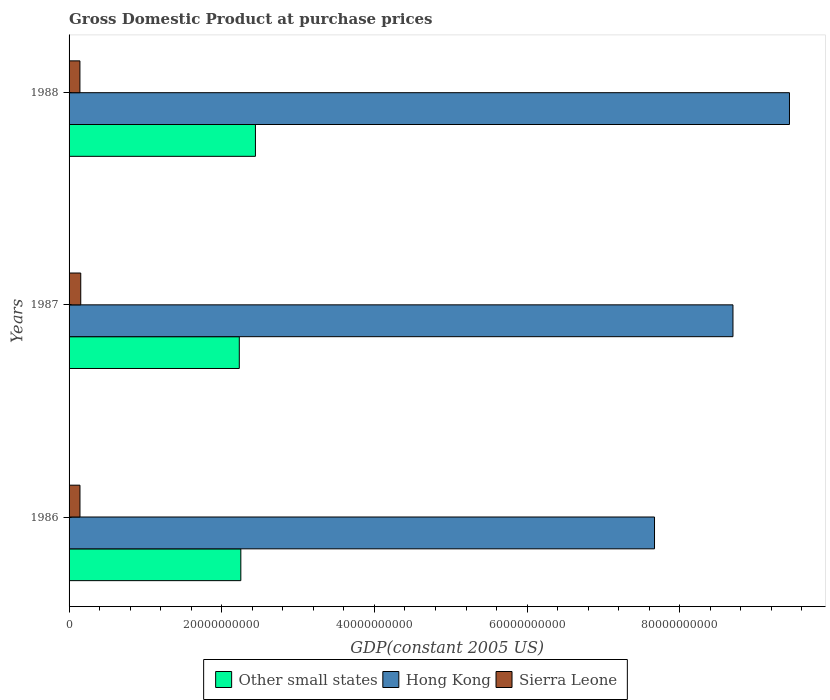How many groups of bars are there?
Your answer should be very brief. 3. Are the number of bars on each tick of the Y-axis equal?
Provide a succinct answer. Yes. How many bars are there on the 3rd tick from the bottom?
Provide a succinct answer. 3. In how many cases, is the number of bars for a given year not equal to the number of legend labels?
Provide a succinct answer. 0. What is the GDP at purchase prices in Other small states in 1988?
Give a very brief answer. 2.44e+1. Across all years, what is the maximum GDP at purchase prices in Other small states?
Ensure brevity in your answer.  2.44e+1. Across all years, what is the minimum GDP at purchase prices in Hong Kong?
Make the answer very short. 7.67e+1. In which year was the GDP at purchase prices in Hong Kong maximum?
Provide a short and direct response. 1988. What is the total GDP at purchase prices in Sierra Leone in the graph?
Provide a short and direct response. 4.38e+09. What is the difference between the GDP at purchase prices in Sierra Leone in 1986 and that in 1988?
Your response must be concise. 5.15e+06. What is the difference between the GDP at purchase prices in Sierra Leone in 1987 and the GDP at purchase prices in Hong Kong in 1988?
Keep it short and to the point. -9.28e+1. What is the average GDP at purchase prices in Sierra Leone per year?
Your response must be concise. 1.46e+09. In the year 1987, what is the difference between the GDP at purchase prices in Sierra Leone and GDP at purchase prices in Other small states?
Ensure brevity in your answer.  -2.08e+1. In how many years, is the GDP at purchase prices in Other small states greater than 68000000000 US$?
Ensure brevity in your answer.  0. What is the ratio of the GDP at purchase prices in Hong Kong in 1987 to that in 1988?
Your answer should be very brief. 0.92. Is the GDP at purchase prices in Other small states in 1987 less than that in 1988?
Make the answer very short. Yes. Is the difference between the GDP at purchase prices in Sierra Leone in 1986 and 1987 greater than the difference between the GDP at purchase prices in Other small states in 1986 and 1987?
Offer a very short reply. No. What is the difference between the highest and the second highest GDP at purchase prices in Hong Kong?
Offer a very short reply. 7.40e+09. What is the difference between the highest and the lowest GDP at purchase prices in Other small states?
Your answer should be very brief. 2.11e+09. In how many years, is the GDP at purchase prices in Other small states greater than the average GDP at purchase prices in Other small states taken over all years?
Keep it short and to the point. 1. Is the sum of the GDP at purchase prices in Hong Kong in 1986 and 1987 greater than the maximum GDP at purchase prices in Other small states across all years?
Ensure brevity in your answer.  Yes. What does the 3rd bar from the top in 1986 represents?
Give a very brief answer. Other small states. What does the 1st bar from the bottom in 1986 represents?
Ensure brevity in your answer.  Other small states. Is it the case that in every year, the sum of the GDP at purchase prices in Other small states and GDP at purchase prices in Hong Kong is greater than the GDP at purchase prices in Sierra Leone?
Offer a very short reply. Yes. How many bars are there?
Provide a short and direct response. 9. How many years are there in the graph?
Your answer should be compact. 3. Are the values on the major ticks of X-axis written in scientific E-notation?
Your response must be concise. No. Does the graph contain grids?
Provide a short and direct response. No. Where does the legend appear in the graph?
Your answer should be very brief. Bottom center. What is the title of the graph?
Your answer should be compact. Gross Domestic Product at purchase prices. What is the label or title of the X-axis?
Give a very brief answer. GDP(constant 2005 US). What is the GDP(constant 2005 US) of Other small states in 1986?
Your answer should be compact. 2.25e+1. What is the GDP(constant 2005 US) of Hong Kong in 1986?
Provide a succinct answer. 7.67e+1. What is the GDP(constant 2005 US) in Sierra Leone in 1986?
Provide a succinct answer. 1.43e+09. What is the GDP(constant 2005 US) in Other small states in 1987?
Your answer should be very brief. 2.23e+1. What is the GDP(constant 2005 US) of Hong Kong in 1987?
Your answer should be very brief. 8.70e+1. What is the GDP(constant 2005 US) of Sierra Leone in 1987?
Ensure brevity in your answer.  1.53e+09. What is the GDP(constant 2005 US) in Other small states in 1988?
Offer a very short reply. 2.44e+1. What is the GDP(constant 2005 US) of Hong Kong in 1988?
Offer a very short reply. 9.44e+1. What is the GDP(constant 2005 US) of Sierra Leone in 1988?
Provide a short and direct response. 1.42e+09. Across all years, what is the maximum GDP(constant 2005 US) of Other small states?
Your response must be concise. 2.44e+1. Across all years, what is the maximum GDP(constant 2005 US) of Hong Kong?
Offer a very short reply. 9.44e+1. Across all years, what is the maximum GDP(constant 2005 US) of Sierra Leone?
Keep it short and to the point. 1.53e+09. Across all years, what is the minimum GDP(constant 2005 US) in Other small states?
Ensure brevity in your answer.  2.23e+1. Across all years, what is the minimum GDP(constant 2005 US) of Hong Kong?
Your answer should be very brief. 7.67e+1. Across all years, what is the minimum GDP(constant 2005 US) in Sierra Leone?
Keep it short and to the point. 1.42e+09. What is the total GDP(constant 2005 US) of Other small states in the graph?
Your answer should be compact. 6.92e+1. What is the total GDP(constant 2005 US) in Hong Kong in the graph?
Give a very brief answer. 2.58e+11. What is the total GDP(constant 2005 US) in Sierra Leone in the graph?
Provide a succinct answer. 4.38e+09. What is the difference between the GDP(constant 2005 US) in Other small states in 1986 and that in 1987?
Keep it short and to the point. 2.00e+08. What is the difference between the GDP(constant 2005 US) of Hong Kong in 1986 and that in 1987?
Provide a succinct answer. -1.03e+1. What is the difference between the GDP(constant 2005 US) of Sierra Leone in 1986 and that in 1987?
Ensure brevity in your answer.  -1.03e+08. What is the difference between the GDP(constant 2005 US) of Other small states in 1986 and that in 1988?
Provide a short and direct response. -1.91e+09. What is the difference between the GDP(constant 2005 US) in Hong Kong in 1986 and that in 1988?
Ensure brevity in your answer.  -1.77e+1. What is the difference between the GDP(constant 2005 US) of Sierra Leone in 1986 and that in 1988?
Your answer should be very brief. 5.15e+06. What is the difference between the GDP(constant 2005 US) of Other small states in 1987 and that in 1988?
Provide a succinct answer. -2.11e+09. What is the difference between the GDP(constant 2005 US) of Hong Kong in 1987 and that in 1988?
Your answer should be compact. -7.40e+09. What is the difference between the GDP(constant 2005 US) of Sierra Leone in 1987 and that in 1988?
Keep it short and to the point. 1.08e+08. What is the difference between the GDP(constant 2005 US) of Other small states in 1986 and the GDP(constant 2005 US) of Hong Kong in 1987?
Provide a succinct answer. -6.45e+1. What is the difference between the GDP(constant 2005 US) in Other small states in 1986 and the GDP(constant 2005 US) in Sierra Leone in 1987?
Provide a short and direct response. 2.10e+1. What is the difference between the GDP(constant 2005 US) of Hong Kong in 1986 and the GDP(constant 2005 US) of Sierra Leone in 1987?
Keep it short and to the point. 7.52e+1. What is the difference between the GDP(constant 2005 US) in Other small states in 1986 and the GDP(constant 2005 US) in Hong Kong in 1988?
Keep it short and to the point. -7.19e+1. What is the difference between the GDP(constant 2005 US) of Other small states in 1986 and the GDP(constant 2005 US) of Sierra Leone in 1988?
Provide a short and direct response. 2.11e+1. What is the difference between the GDP(constant 2005 US) in Hong Kong in 1986 and the GDP(constant 2005 US) in Sierra Leone in 1988?
Make the answer very short. 7.53e+1. What is the difference between the GDP(constant 2005 US) in Other small states in 1987 and the GDP(constant 2005 US) in Hong Kong in 1988?
Offer a terse response. -7.21e+1. What is the difference between the GDP(constant 2005 US) of Other small states in 1987 and the GDP(constant 2005 US) of Sierra Leone in 1988?
Your response must be concise. 2.09e+1. What is the difference between the GDP(constant 2005 US) in Hong Kong in 1987 and the GDP(constant 2005 US) in Sierra Leone in 1988?
Give a very brief answer. 8.55e+1. What is the average GDP(constant 2005 US) in Other small states per year?
Make the answer very short. 2.31e+1. What is the average GDP(constant 2005 US) in Hong Kong per year?
Your response must be concise. 8.60e+1. What is the average GDP(constant 2005 US) in Sierra Leone per year?
Keep it short and to the point. 1.46e+09. In the year 1986, what is the difference between the GDP(constant 2005 US) of Other small states and GDP(constant 2005 US) of Hong Kong?
Your answer should be compact. -5.42e+1. In the year 1986, what is the difference between the GDP(constant 2005 US) of Other small states and GDP(constant 2005 US) of Sierra Leone?
Offer a terse response. 2.11e+1. In the year 1986, what is the difference between the GDP(constant 2005 US) in Hong Kong and GDP(constant 2005 US) in Sierra Leone?
Ensure brevity in your answer.  7.53e+1. In the year 1987, what is the difference between the GDP(constant 2005 US) of Other small states and GDP(constant 2005 US) of Hong Kong?
Ensure brevity in your answer.  -6.47e+1. In the year 1987, what is the difference between the GDP(constant 2005 US) in Other small states and GDP(constant 2005 US) in Sierra Leone?
Keep it short and to the point. 2.08e+1. In the year 1987, what is the difference between the GDP(constant 2005 US) of Hong Kong and GDP(constant 2005 US) of Sierra Leone?
Make the answer very short. 8.54e+1. In the year 1988, what is the difference between the GDP(constant 2005 US) of Other small states and GDP(constant 2005 US) of Hong Kong?
Provide a short and direct response. -6.99e+1. In the year 1988, what is the difference between the GDP(constant 2005 US) of Other small states and GDP(constant 2005 US) of Sierra Leone?
Offer a terse response. 2.30e+1. In the year 1988, what is the difference between the GDP(constant 2005 US) of Hong Kong and GDP(constant 2005 US) of Sierra Leone?
Provide a short and direct response. 9.29e+1. What is the ratio of the GDP(constant 2005 US) in Hong Kong in 1986 to that in 1987?
Provide a succinct answer. 0.88. What is the ratio of the GDP(constant 2005 US) of Sierra Leone in 1986 to that in 1987?
Provide a short and direct response. 0.93. What is the ratio of the GDP(constant 2005 US) of Other small states in 1986 to that in 1988?
Offer a terse response. 0.92. What is the ratio of the GDP(constant 2005 US) in Hong Kong in 1986 to that in 1988?
Ensure brevity in your answer.  0.81. What is the ratio of the GDP(constant 2005 US) of Sierra Leone in 1986 to that in 1988?
Offer a very short reply. 1. What is the ratio of the GDP(constant 2005 US) of Other small states in 1987 to that in 1988?
Ensure brevity in your answer.  0.91. What is the ratio of the GDP(constant 2005 US) of Hong Kong in 1987 to that in 1988?
Your response must be concise. 0.92. What is the ratio of the GDP(constant 2005 US) in Sierra Leone in 1987 to that in 1988?
Your response must be concise. 1.08. What is the difference between the highest and the second highest GDP(constant 2005 US) in Other small states?
Provide a succinct answer. 1.91e+09. What is the difference between the highest and the second highest GDP(constant 2005 US) in Hong Kong?
Provide a succinct answer. 7.40e+09. What is the difference between the highest and the second highest GDP(constant 2005 US) of Sierra Leone?
Your answer should be compact. 1.03e+08. What is the difference between the highest and the lowest GDP(constant 2005 US) in Other small states?
Provide a short and direct response. 2.11e+09. What is the difference between the highest and the lowest GDP(constant 2005 US) of Hong Kong?
Offer a very short reply. 1.77e+1. What is the difference between the highest and the lowest GDP(constant 2005 US) in Sierra Leone?
Make the answer very short. 1.08e+08. 